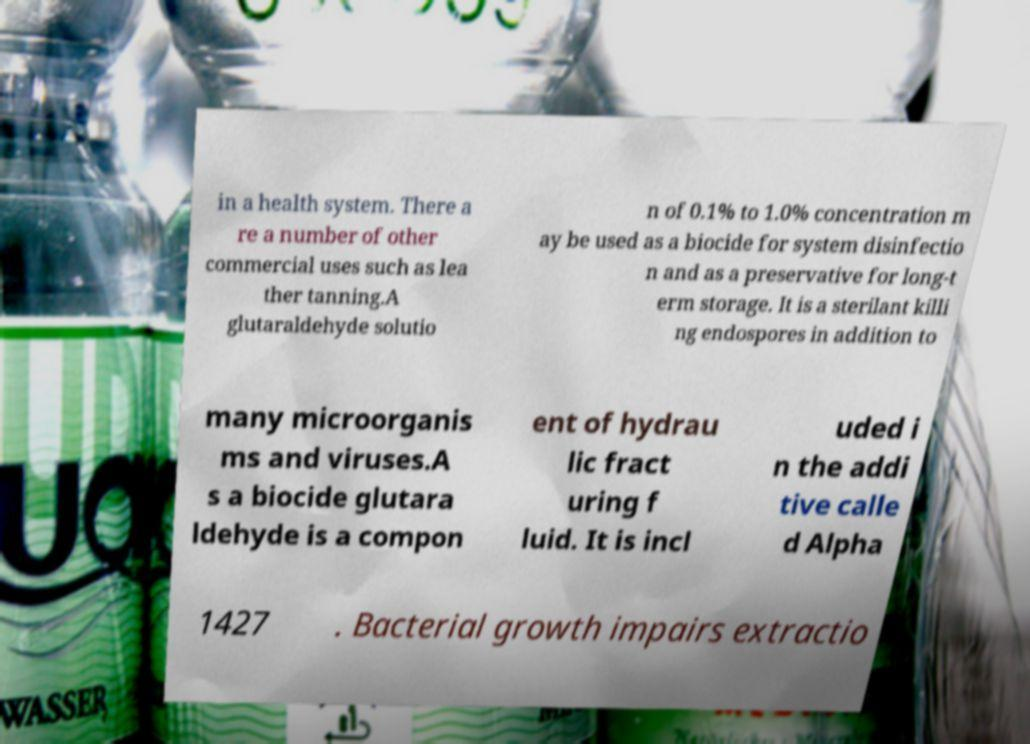Could you extract and type out the text from this image? in a health system. There a re a number of other commercial uses such as lea ther tanning.A glutaraldehyde solutio n of 0.1% to 1.0% concentration m ay be used as a biocide for system disinfectio n and as a preservative for long-t erm storage. It is a sterilant killi ng endospores in addition to many microorganis ms and viruses.A s a biocide glutara ldehyde is a compon ent of hydrau lic fract uring f luid. It is incl uded i n the addi tive calle d Alpha 1427 . Bacterial growth impairs extractio 